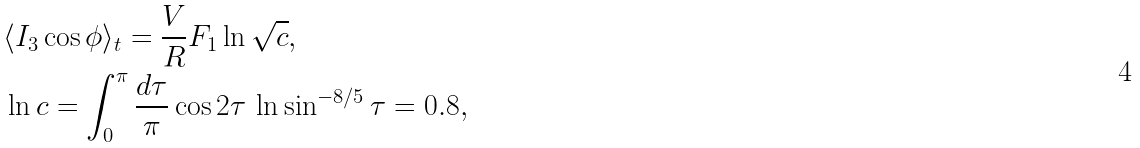Convert formula to latex. <formula><loc_0><loc_0><loc_500><loc_500>& \langle I _ { 3 } \cos \phi \rangle _ { t } = \frac { V } { R } F _ { 1 } \ln \sqrt { c } , \\ & \ln c = \int _ { 0 } ^ { \pi } \frac { d \tau } { \pi } \cos 2 \tau \, \ln \sin ^ { - 8 / 5 } \tau = 0 . 8 ,</formula> 